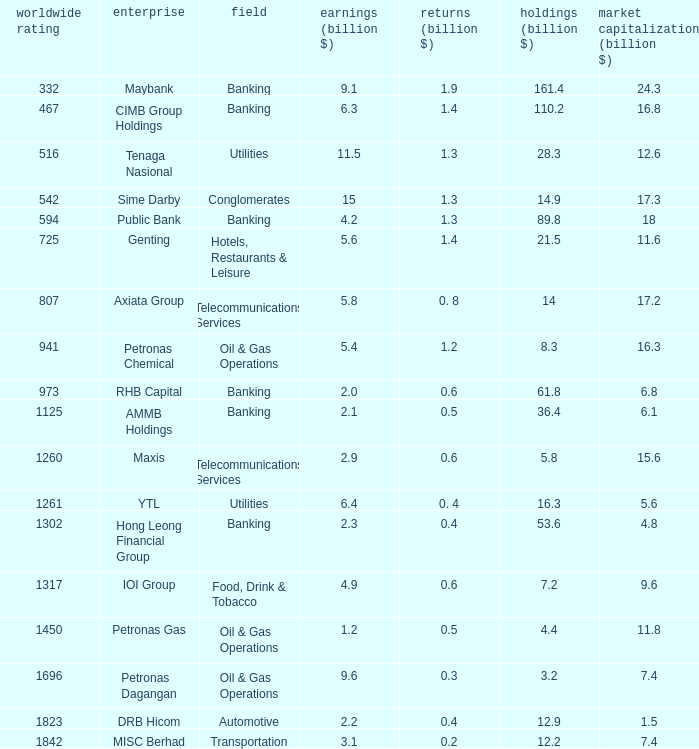Name the market value for rhb capital 6.8. Could you parse the entire table as a dict? {'header': ['worldwide rating', 'enterprise', 'field', 'earnings (billion $)', 'returns (billion $)', 'holdings (billion $)', 'market capitalization (billion $)'], 'rows': [['332', 'Maybank', 'Banking', '9.1', '1.9', '161.4', '24.3'], ['467', 'CIMB Group Holdings', 'Banking', '6.3', '1.4', '110.2', '16.8'], ['516', 'Tenaga Nasional', 'Utilities', '11.5', '1.3', '28.3', '12.6'], ['542', 'Sime Darby', 'Conglomerates', '15', '1.3', '14.9', '17.3'], ['594', 'Public Bank', 'Banking', '4.2', '1.3', '89.8', '18'], ['725', 'Genting', 'Hotels, Restaurants & Leisure', '5.6', '1.4', '21.5', '11.6'], ['807', 'Axiata Group', 'Telecommunications Services', '5.8', '0. 8', '14', '17.2'], ['941', 'Petronas Chemical', 'Oil & Gas Operations', '5.4', '1.2', '8.3', '16.3'], ['973', 'RHB Capital', 'Banking', '2.0', '0.6', '61.8', '6.8'], ['1125', 'AMMB Holdings', 'Banking', '2.1', '0.5', '36.4', '6.1'], ['1260', 'Maxis', 'Telecommunications Services', '2.9', '0.6', '5.8', '15.6'], ['1261', 'YTL', 'Utilities', '6.4', '0. 4', '16.3', '5.6'], ['1302', 'Hong Leong Financial Group', 'Banking', '2.3', '0.4', '53.6', '4.8'], ['1317', 'IOI Group', 'Food, Drink & Tobacco', '4.9', '0.6', '7.2', '9.6'], ['1450', 'Petronas Gas', 'Oil & Gas Operations', '1.2', '0.5', '4.4', '11.8'], ['1696', 'Petronas Dagangan', 'Oil & Gas Operations', '9.6', '0.3', '3.2', '7.4'], ['1823', 'DRB Hicom', 'Automotive', '2.2', '0.4', '12.9', '1.5'], ['1842', 'MISC Berhad', 'Transportation', '3.1', '0.2', '12.2', '7.4']]} 